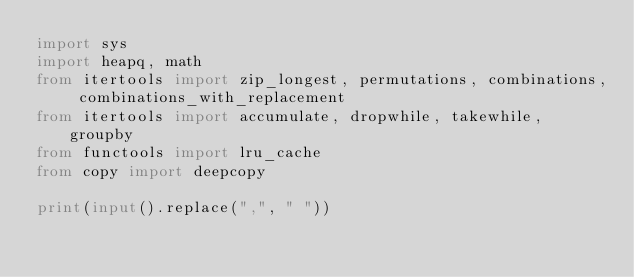<code> <loc_0><loc_0><loc_500><loc_500><_Python_>import sys
import heapq, math
from itertools import zip_longest, permutations, combinations, combinations_with_replacement
from itertools import accumulate, dropwhile, takewhile, groupby
from functools import lru_cache
from copy import deepcopy

print(input().replace(",", " "))</code> 